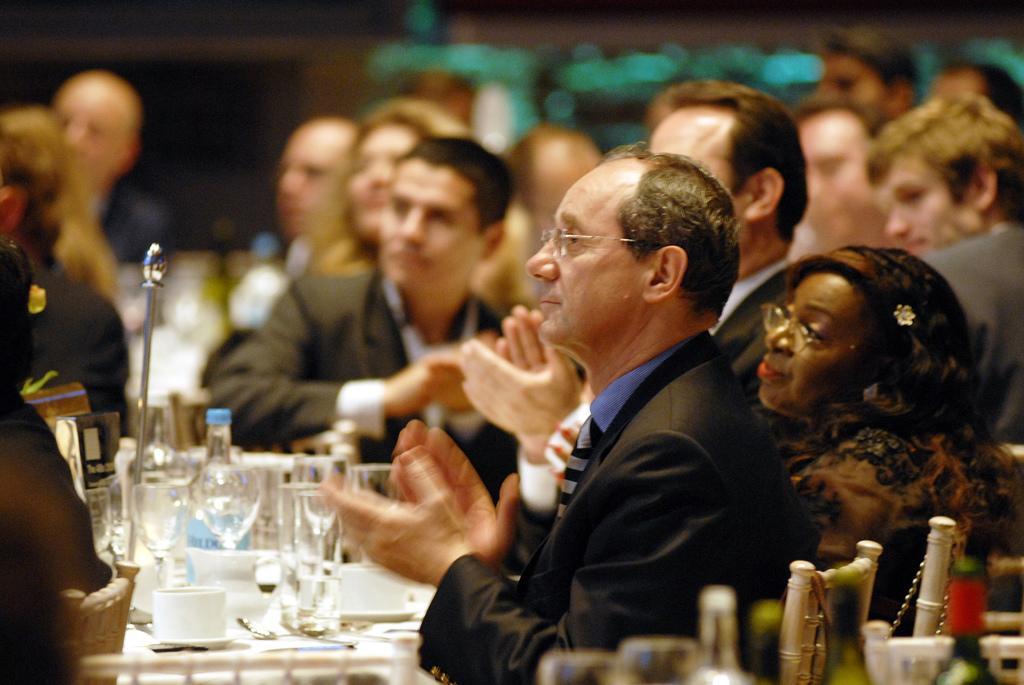Describe this image in one or two sentences. In this image we can see many people sitting on chairs. Two are wearing specs. And we can see glasses, bottles, cups and saucers. In the background it is looking blur. 